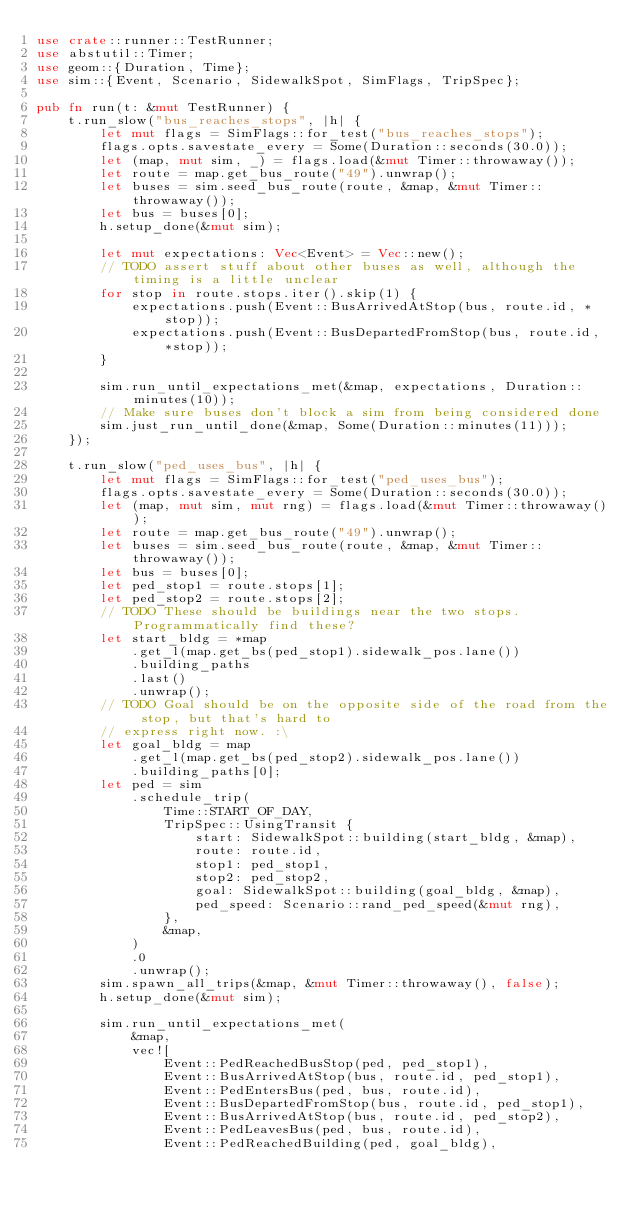Convert code to text. <code><loc_0><loc_0><loc_500><loc_500><_Rust_>use crate::runner::TestRunner;
use abstutil::Timer;
use geom::{Duration, Time};
use sim::{Event, Scenario, SidewalkSpot, SimFlags, TripSpec};

pub fn run(t: &mut TestRunner) {
    t.run_slow("bus_reaches_stops", |h| {
        let mut flags = SimFlags::for_test("bus_reaches_stops");
        flags.opts.savestate_every = Some(Duration::seconds(30.0));
        let (map, mut sim, _) = flags.load(&mut Timer::throwaway());
        let route = map.get_bus_route("49").unwrap();
        let buses = sim.seed_bus_route(route, &map, &mut Timer::throwaway());
        let bus = buses[0];
        h.setup_done(&mut sim);

        let mut expectations: Vec<Event> = Vec::new();
        // TODO assert stuff about other buses as well, although the timing is a little unclear
        for stop in route.stops.iter().skip(1) {
            expectations.push(Event::BusArrivedAtStop(bus, route.id, *stop));
            expectations.push(Event::BusDepartedFromStop(bus, route.id, *stop));
        }

        sim.run_until_expectations_met(&map, expectations, Duration::minutes(10));
        // Make sure buses don't block a sim from being considered done
        sim.just_run_until_done(&map, Some(Duration::minutes(11)));
    });

    t.run_slow("ped_uses_bus", |h| {
        let mut flags = SimFlags::for_test("ped_uses_bus");
        flags.opts.savestate_every = Some(Duration::seconds(30.0));
        let (map, mut sim, mut rng) = flags.load(&mut Timer::throwaway());
        let route = map.get_bus_route("49").unwrap();
        let buses = sim.seed_bus_route(route, &map, &mut Timer::throwaway());
        let bus = buses[0];
        let ped_stop1 = route.stops[1];
        let ped_stop2 = route.stops[2];
        // TODO These should be buildings near the two stops. Programmatically find these?
        let start_bldg = *map
            .get_l(map.get_bs(ped_stop1).sidewalk_pos.lane())
            .building_paths
            .last()
            .unwrap();
        // TODO Goal should be on the opposite side of the road from the stop, but that's hard to
        // express right now. :\
        let goal_bldg = map
            .get_l(map.get_bs(ped_stop2).sidewalk_pos.lane())
            .building_paths[0];
        let ped = sim
            .schedule_trip(
                Time::START_OF_DAY,
                TripSpec::UsingTransit {
                    start: SidewalkSpot::building(start_bldg, &map),
                    route: route.id,
                    stop1: ped_stop1,
                    stop2: ped_stop2,
                    goal: SidewalkSpot::building(goal_bldg, &map),
                    ped_speed: Scenario::rand_ped_speed(&mut rng),
                },
                &map,
            )
            .0
            .unwrap();
        sim.spawn_all_trips(&map, &mut Timer::throwaway(), false);
        h.setup_done(&mut sim);

        sim.run_until_expectations_met(
            &map,
            vec![
                Event::PedReachedBusStop(ped, ped_stop1),
                Event::BusArrivedAtStop(bus, route.id, ped_stop1),
                Event::PedEntersBus(ped, bus, route.id),
                Event::BusDepartedFromStop(bus, route.id, ped_stop1),
                Event::BusArrivedAtStop(bus, route.id, ped_stop2),
                Event::PedLeavesBus(ped, bus, route.id),
                Event::PedReachedBuilding(ped, goal_bldg),</code> 